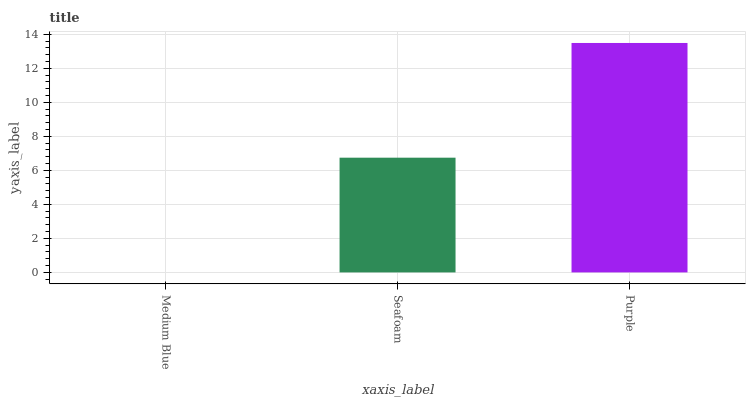Is Medium Blue the minimum?
Answer yes or no. Yes. Is Purple the maximum?
Answer yes or no. Yes. Is Seafoam the minimum?
Answer yes or no. No. Is Seafoam the maximum?
Answer yes or no. No. Is Seafoam greater than Medium Blue?
Answer yes or no. Yes. Is Medium Blue less than Seafoam?
Answer yes or no. Yes. Is Medium Blue greater than Seafoam?
Answer yes or no. No. Is Seafoam less than Medium Blue?
Answer yes or no. No. Is Seafoam the high median?
Answer yes or no. Yes. Is Seafoam the low median?
Answer yes or no. Yes. Is Medium Blue the high median?
Answer yes or no. No. Is Purple the low median?
Answer yes or no. No. 